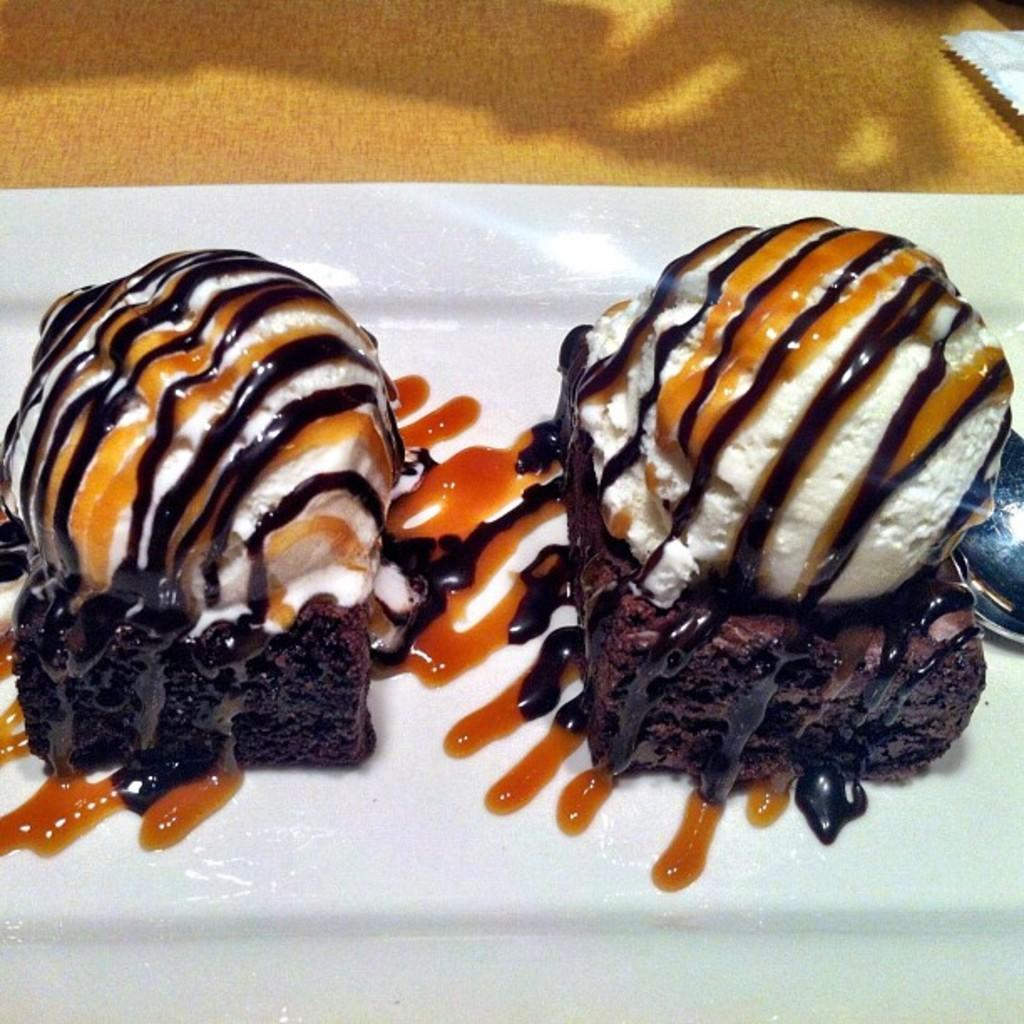What is on the plate that is visible in the image? There are pieces of bread and ice cream on the plate. What utensil can be seen in the image? There is a spoon visible in the image. What is the color of the surface in the image? The surface in the image is yellow. What type of disease is affecting the bread in the image? There is no indication of any disease affecting the bread in the image; it appears to be normal bread. Can you see any beetles crawling on the plate in the image? There are no beetles present in the image. 